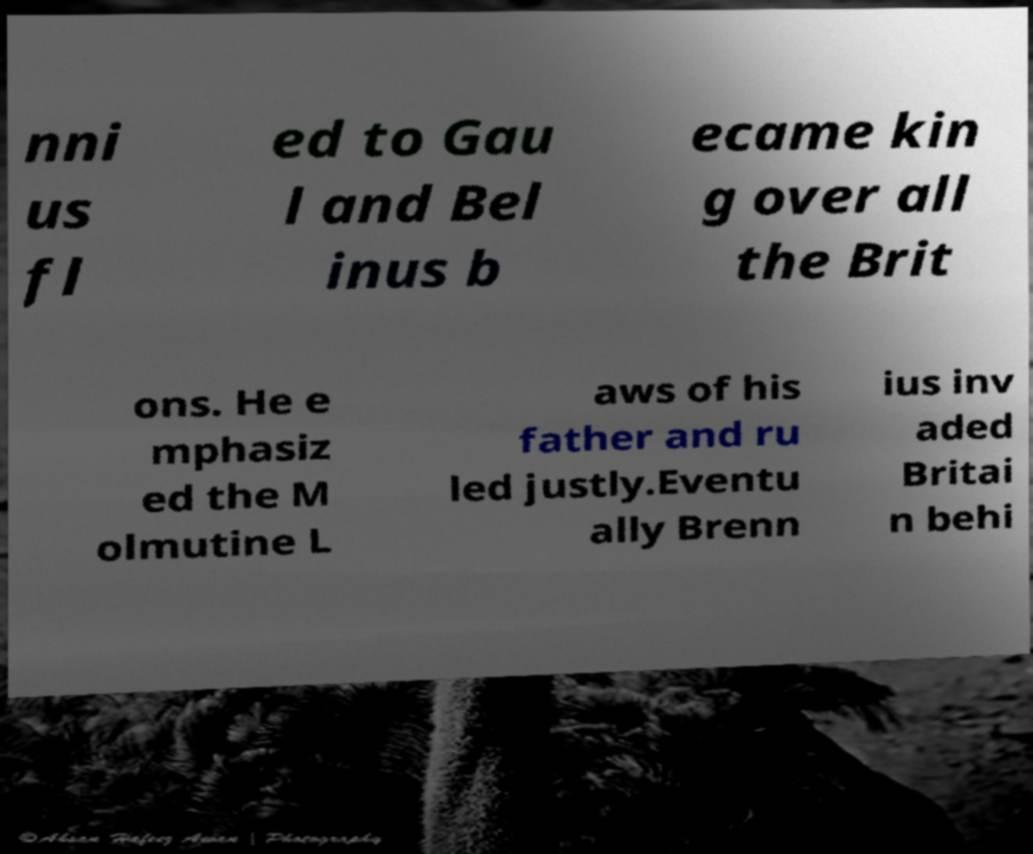There's text embedded in this image that I need extracted. Can you transcribe it verbatim? nni us fl ed to Gau l and Bel inus b ecame kin g over all the Brit ons. He e mphasiz ed the M olmutine L aws of his father and ru led justly.Eventu ally Brenn ius inv aded Britai n behi 